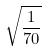Convert formula to latex. <formula><loc_0><loc_0><loc_500><loc_500>\sqrt { \frac { 1 } { 7 0 } }</formula> 